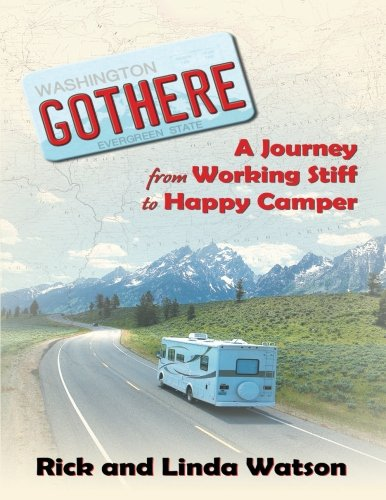What is the genre of this book? The genre of the book is travel, which is evident from the subtitle 'A Journey From Working Stiff to Happy Camper' and the image of a road trip on the cover, which typically signifies adventure and exploration. 